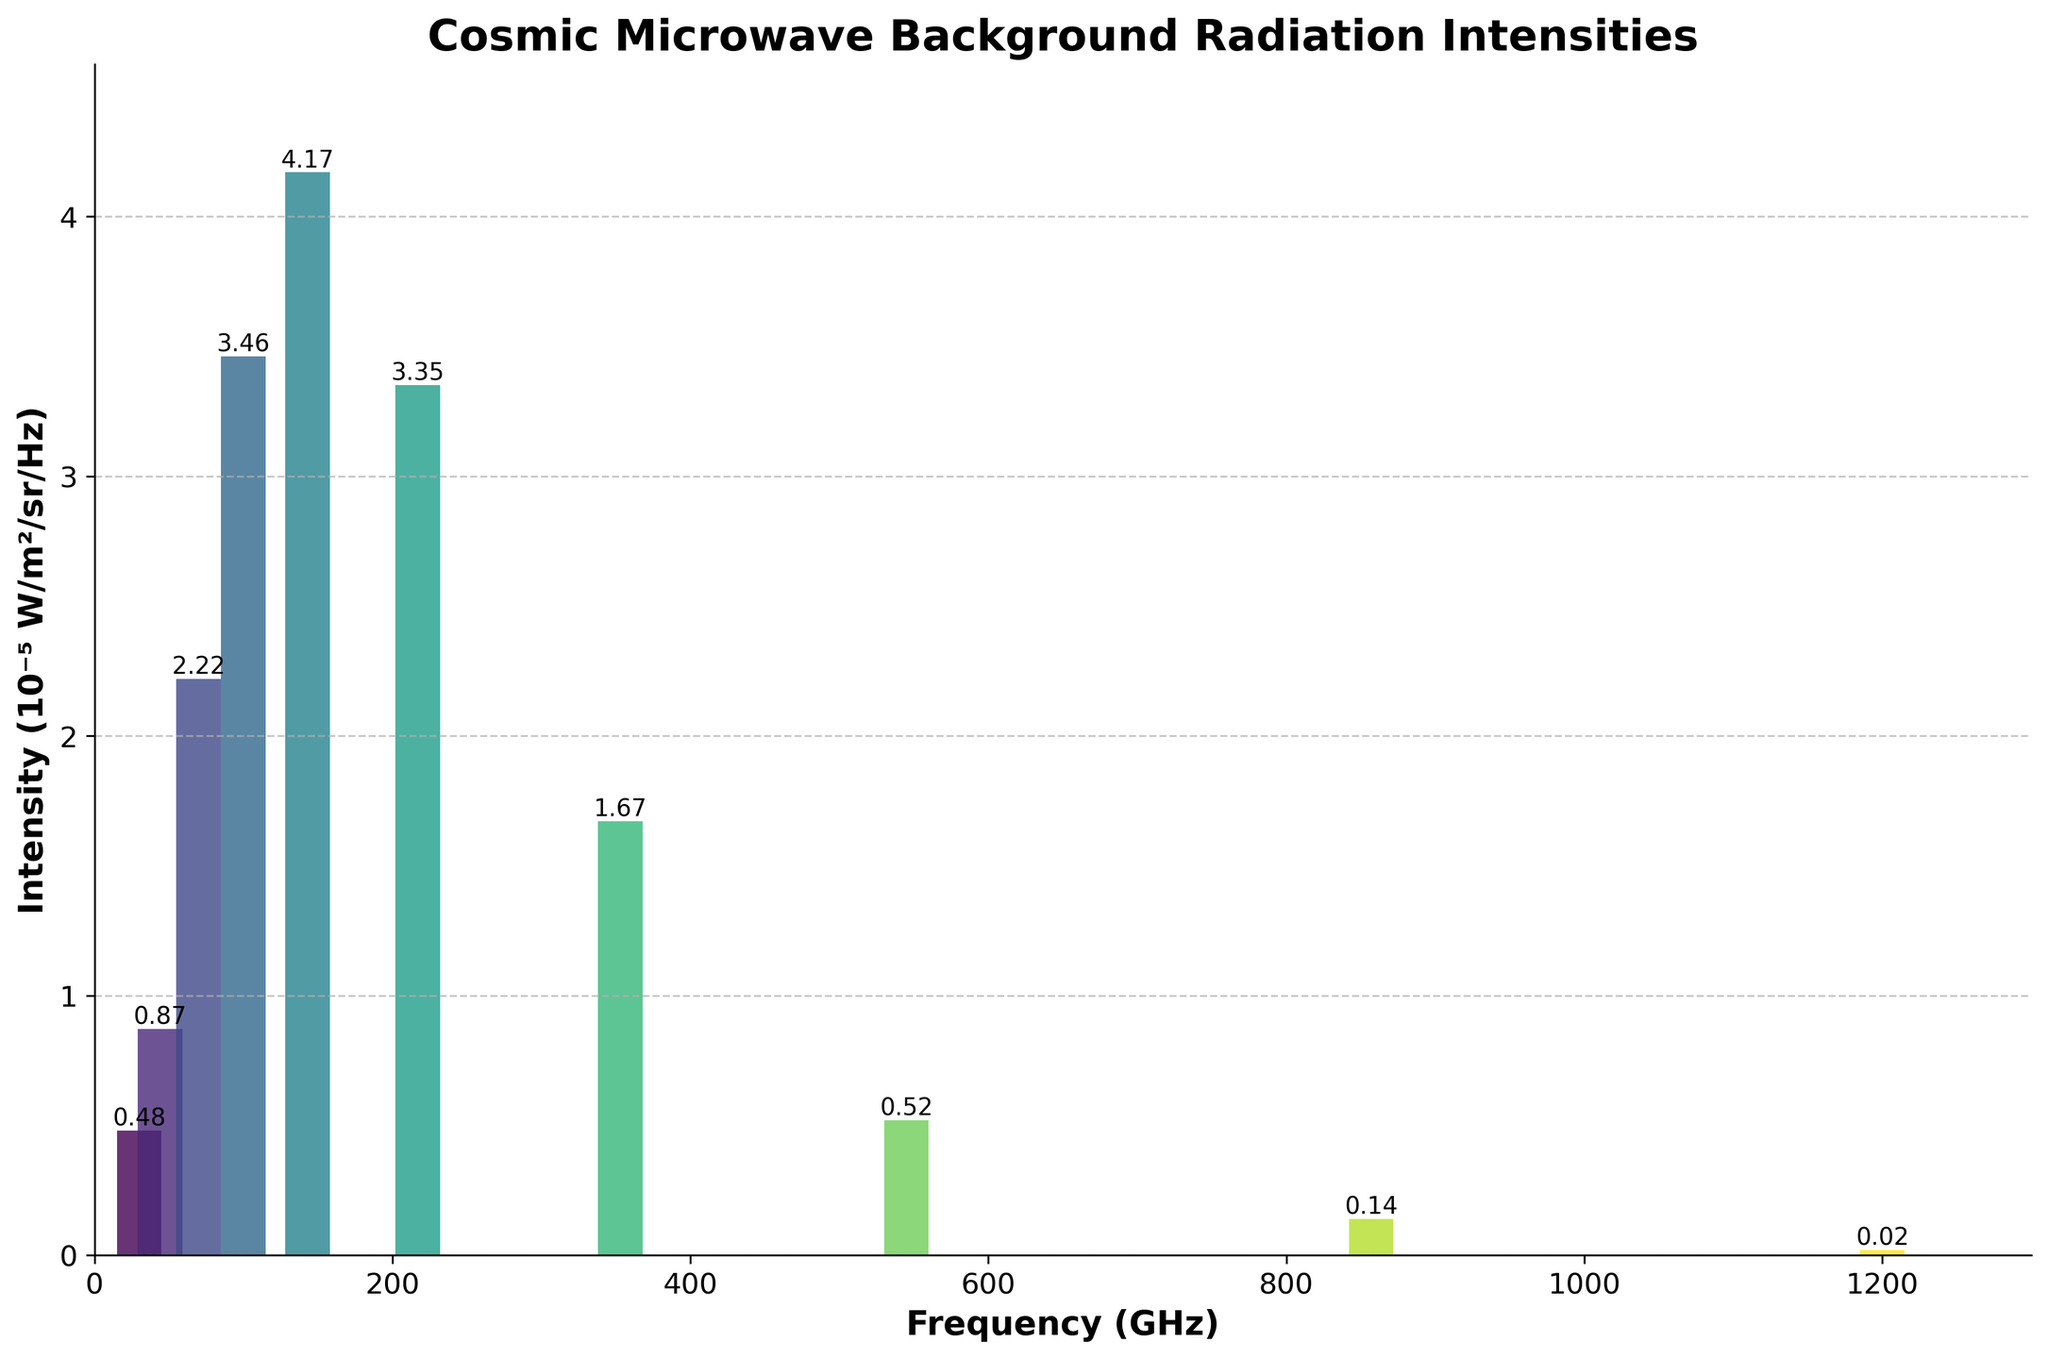What is the frequency with the highest intensity of cosmic microwave background radiation? By observing the bar chart, the frequency with the highest intensity can be identified as the tallest bar. The tallest bar corresponds to the frequency of 143 GHz.
Answer: 143 GHz Which frequency has an intensity less than 1 but more than 0.5 (in 10⁻⁵ W/m²/sr/Hz)? To answer this, observe the bars that lie within the given intensity range. The frequencies that fall into this range are 30 GHz (0.48), 44 GHz (0.87), and 545 GHz (0.52). Among these, only the bar corresponding to 44 GHz (0.87) and 545 GHz (0.52) meet the criteria.
Answer: 44 GHz, 545 GHz What is the sum of the intensities of cosmic microwave background radiation for the frequencies 70 GHz, 100 GHz, and 143 GHz? Check the bars corresponding to these frequencies. The intensities for 70 GHz, 100 GHz, and 143 GHz are 2.22, 3.46, and 4.17 (in 10⁻⁵ W/m²/sr/Hz) respectively. Sum these values: 2.22 + 3.46 + 4.17 = 9.85.
Answer: 9.85 How does the intensity at 217 GHz compare with the intensity at 353 GHz? Compare the heights of the bars for 217 GHz and 353 GHz. The bar for 217 GHz is taller than for 353 GHz, meaning the intensity at 217 GHz (3.35) is greater than 353 GHz (1.67).
Answer: 217 GHz is greater What is the average intensity across all listed frequencies? Calculate the sum of all intensities and divide by the number of frequencies (10). The sum of the intensities is 0.48 + 0.87 + 2.22 + 3.46 + 4.17 + 3.35 + 1.67 + 0.52 + 0.14 + 0.02 = 16.90. Divide by 10: 16.90 / 10 = 1.69.
Answer: 1.69 Among the frequencies listed, which one has the lowest intensity? Identify the shortest bar in the chart. The shortest bar corresponds to 1200 GHz with an intensity of 0.02.
Answer: 1200 GHz What is the intensity difference between the frequencies 100 GHz and 30 GHz? Find the intensities for 100 GHz (3.46) and 30 GHz (0.48). Calculate the difference: 3.46 - 0.48 = 2.98.
Answer: 2.98 What's the combined intensity for the frequencies with intensities greater than 3 (in 10⁻⁵ W/m²/sr/Hz)? Identify the bars with intensities >3: 100 GHz (3.46), 143 GHz (4.17), and 217 GHz (3.35). Sum these values: 3.46 + 4.17 + 3.35 = 10.98.
Answer: 10.98 How many frequencies have intensities less than 1 (in 10⁻⁵ W/m²/sr/Hz)? Look at the bars with intensities <1: 30 GHz (0.48), 44 GHz (0.87), 545 GHz (0.52), 857 GHz (0.14), and 1200 GHz (0.02). Count these frequencies, totaling 5.
Answer: 5 